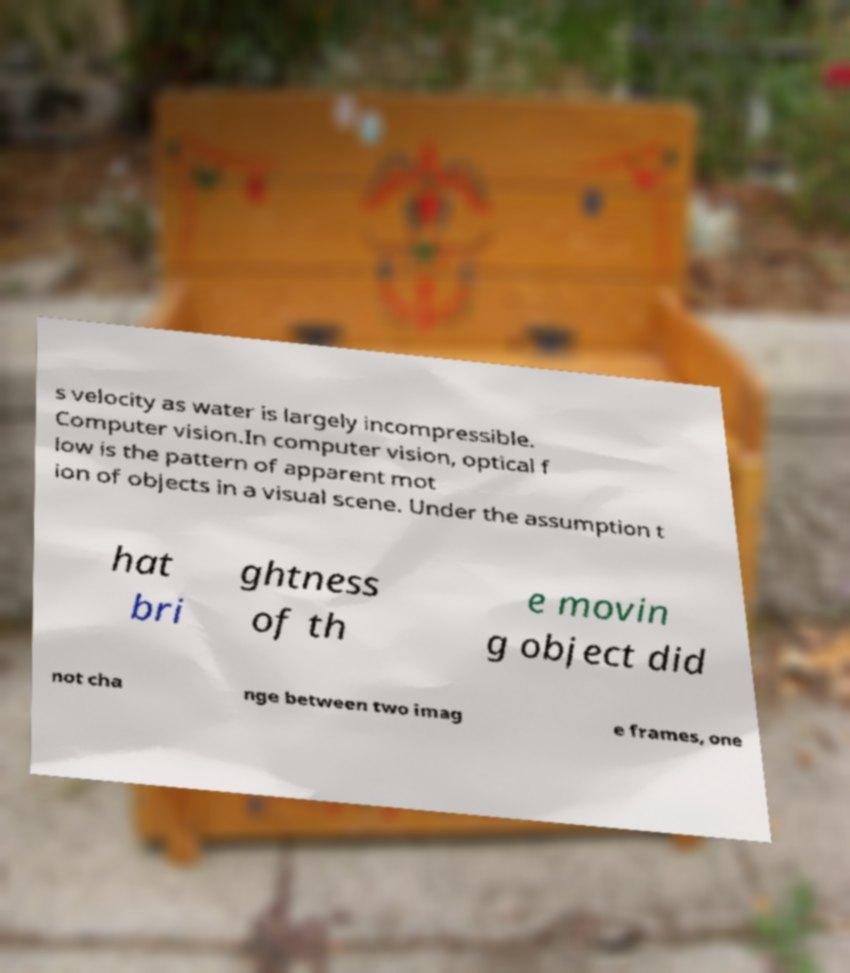Could you assist in decoding the text presented in this image and type it out clearly? s velocity as water is largely incompressible. Computer vision.In computer vision, optical f low is the pattern of apparent mot ion of objects in a visual scene. Under the assumption t hat bri ghtness of th e movin g object did not cha nge between two imag e frames, one 